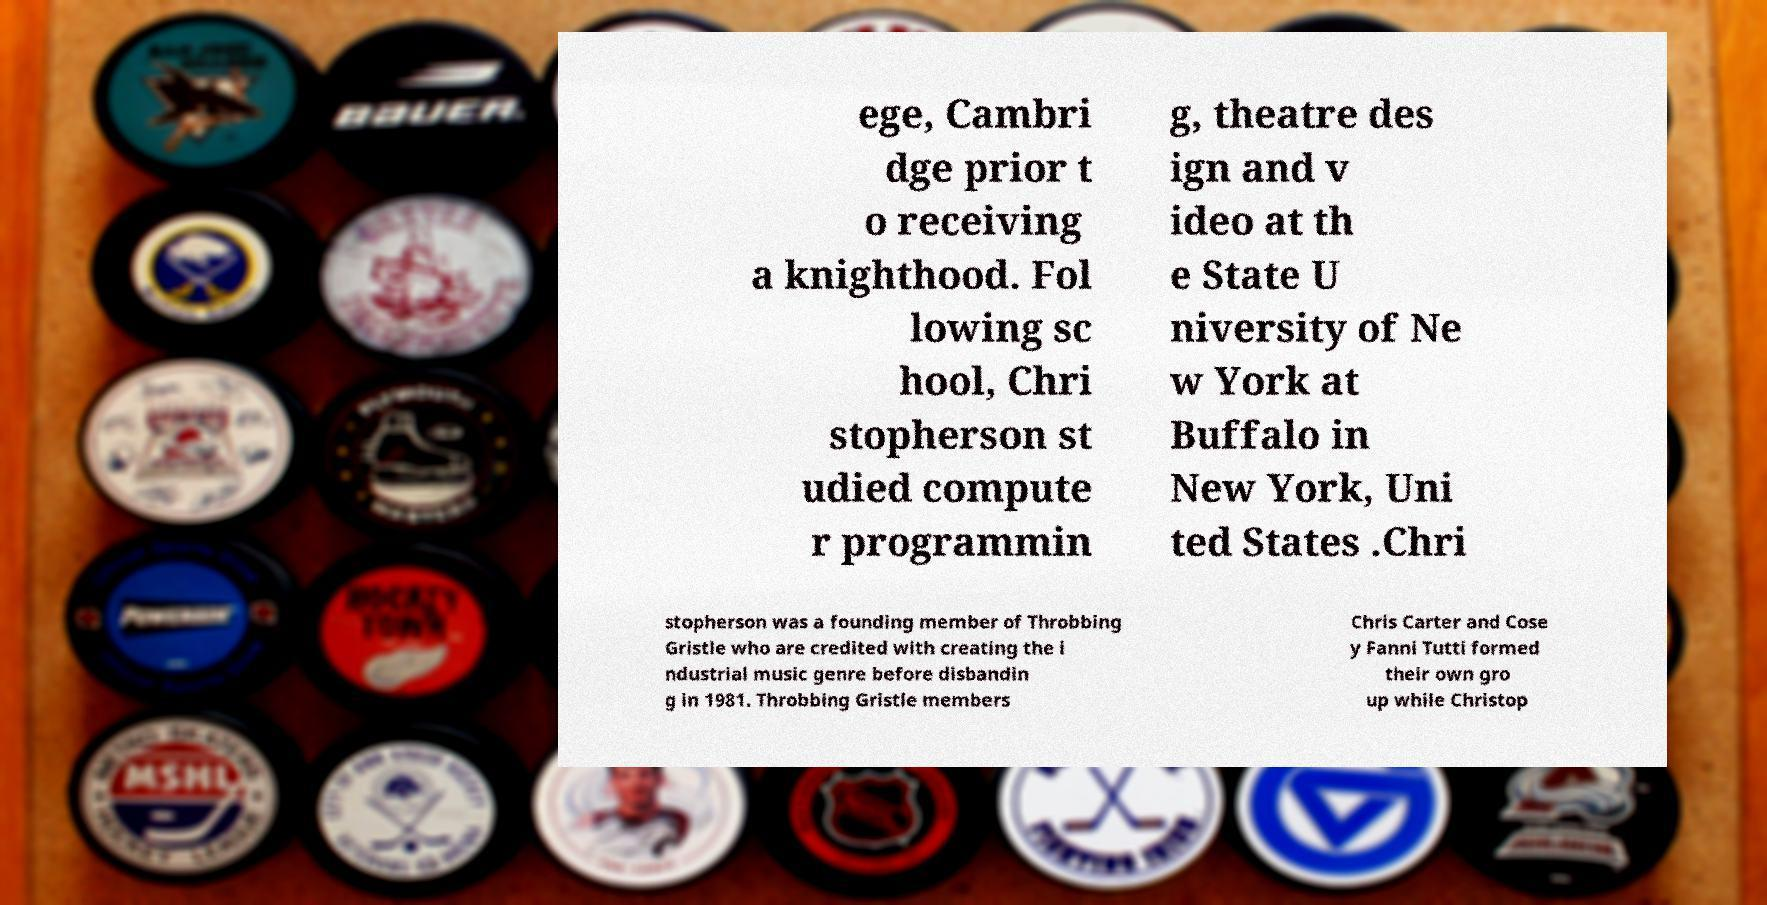I need the written content from this picture converted into text. Can you do that? ege, Cambri dge prior t o receiving a knighthood. Fol lowing sc hool, Chri stopherson st udied compute r programmin g, theatre des ign and v ideo at th e State U niversity of Ne w York at Buffalo in New York, Uni ted States .Chri stopherson was a founding member of Throbbing Gristle who are credited with creating the i ndustrial music genre before disbandin g in 1981. Throbbing Gristle members Chris Carter and Cose y Fanni Tutti formed their own gro up while Christop 